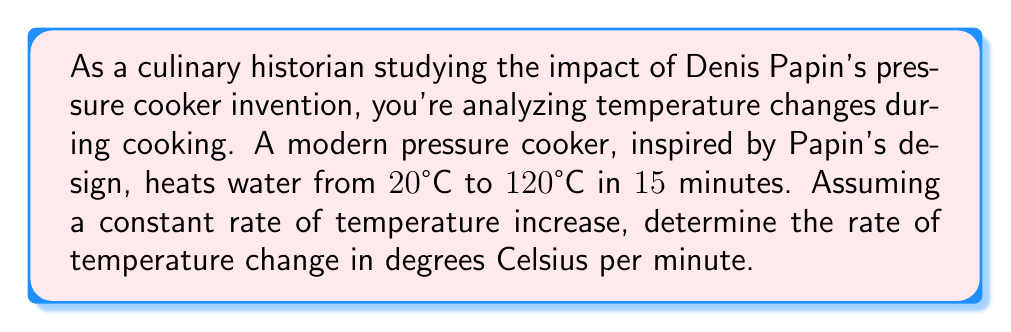Solve this math problem. To solve this problem, we need to follow these steps:

1. Identify the given information:
   - Initial temperature: $20°C$
   - Final temperature: $120°C$
   - Time taken: $15$ minutes

2. Calculate the total temperature change:
   $$\text{Temperature change} = \text{Final temperature} - \text{Initial temperature}$$
   $$\text{Temperature change} = 120°C - 20°C = 100°C$$

3. Calculate the rate of temperature change using the formula:
   $$\text{Rate of change} = \frac{\text{Change in quantity}}{\text{Change in time}}$$

   In this case:
   $$\text{Rate of temperature change} = \frac{\text{Temperature change}}{\text{Time taken}}$$

4. Substitute the values:
   $$\text{Rate of temperature change} = \frac{100°C}{15 \text{ minutes}}$$

5. Perform the division:
   $$\text{Rate of temperature change} = \frac{100}{15}°C/\text{min} = 6.67°C/\text{min}$$

Therefore, the rate of temperature change in the pressure cooker is approximately $6.67°C$ per minute.
Answer: $6.67°C/\text{min}$ 